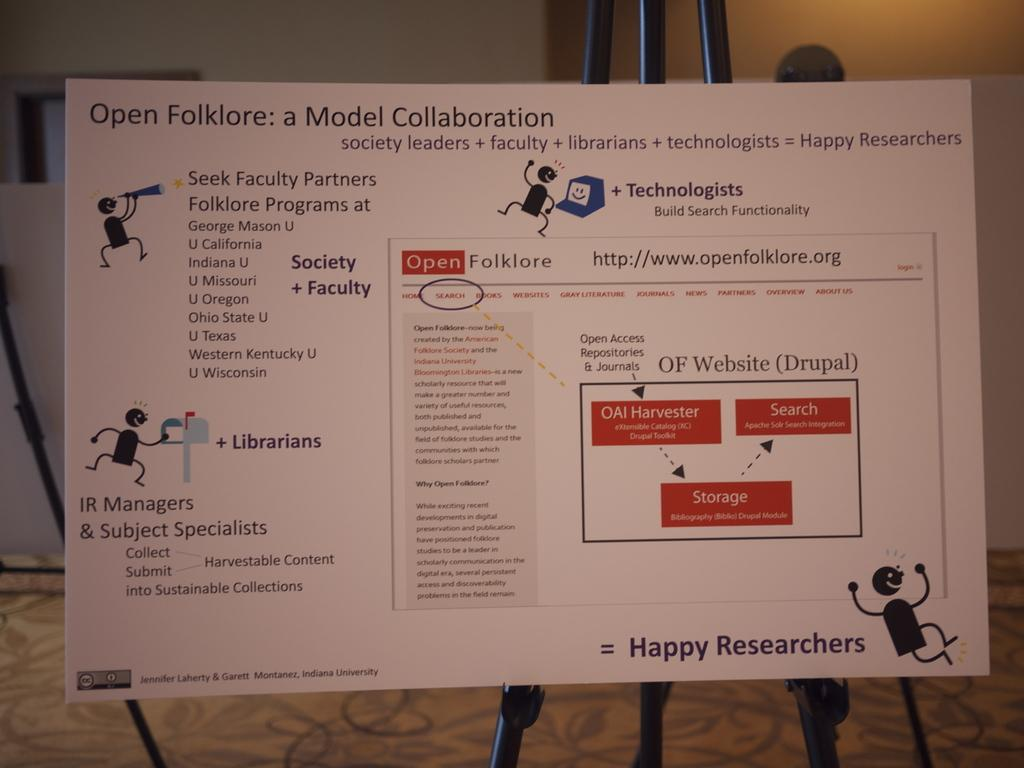<image>
Render a clear and concise summary of the photo. a sign on a stand depicting open folklore and a flow chart 